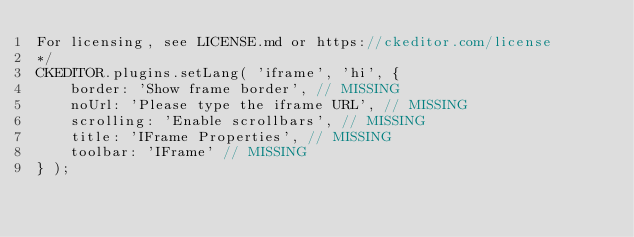<code> <loc_0><loc_0><loc_500><loc_500><_JavaScript_>For licensing, see LICENSE.md or https://ckeditor.com/license
*/
CKEDITOR.plugins.setLang( 'iframe', 'hi', {
	border: 'Show frame border', // MISSING
	noUrl: 'Please type the iframe URL', // MISSING
	scrolling: 'Enable scrollbars', // MISSING
	title: 'IFrame Properties', // MISSING
	toolbar: 'IFrame' // MISSING
} );
</code> 